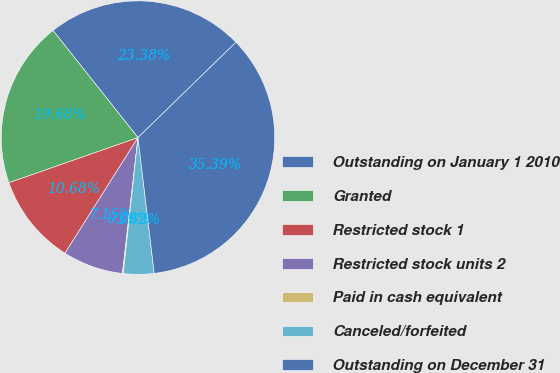Convert chart. <chart><loc_0><loc_0><loc_500><loc_500><pie_chart><fcel>Outstanding on January 1 2010<fcel>Granted<fcel>Restricted stock 1<fcel>Restricted stock units 2<fcel>Paid in cash equivalent<fcel>Canceled/forfeited<fcel>Outstanding on December 31<nl><fcel>23.38%<fcel>19.68%<fcel>10.68%<fcel>7.15%<fcel>0.09%<fcel>3.62%<fcel>35.39%<nl></chart> 